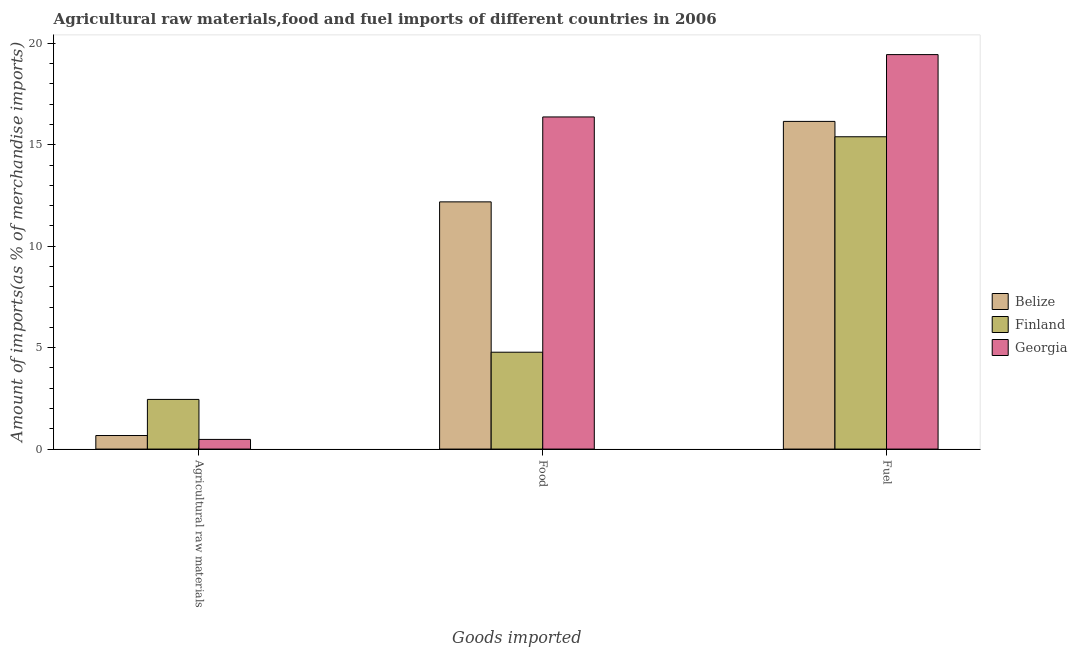How many different coloured bars are there?
Your response must be concise. 3. Are the number of bars per tick equal to the number of legend labels?
Your answer should be compact. Yes. How many bars are there on the 2nd tick from the left?
Ensure brevity in your answer.  3. How many bars are there on the 1st tick from the right?
Keep it short and to the point. 3. What is the label of the 1st group of bars from the left?
Ensure brevity in your answer.  Agricultural raw materials. What is the percentage of raw materials imports in Belize?
Give a very brief answer. 0.67. Across all countries, what is the maximum percentage of raw materials imports?
Your answer should be very brief. 2.45. Across all countries, what is the minimum percentage of fuel imports?
Make the answer very short. 15.39. In which country was the percentage of fuel imports maximum?
Your response must be concise. Georgia. In which country was the percentage of raw materials imports minimum?
Provide a short and direct response. Georgia. What is the total percentage of fuel imports in the graph?
Provide a short and direct response. 50.99. What is the difference between the percentage of fuel imports in Finland and that in Georgia?
Provide a succinct answer. -4.05. What is the difference between the percentage of food imports in Georgia and the percentage of raw materials imports in Finland?
Ensure brevity in your answer.  13.92. What is the average percentage of food imports per country?
Provide a succinct answer. 11.11. What is the difference between the percentage of food imports and percentage of fuel imports in Finland?
Offer a terse response. -10.62. What is the ratio of the percentage of raw materials imports in Finland to that in Belize?
Provide a short and direct response. 3.66. What is the difference between the highest and the second highest percentage of food imports?
Make the answer very short. 4.19. What is the difference between the highest and the lowest percentage of raw materials imports?
Your answer should be very brief. 1.97. In how many countries, is the percentage of fuel imports greater than the average percentage of fuel imports taken over all countries?
Give a very brief answer. 1. What does the 1st bar from the right in Agricultural raw materials represents?
Your response must be concise. Georgia. Is it the case that in every country, the sum of the percentage of raw materials imports and percentage of food imports is greater than the percentage of fuel imports?
Ensure brevity in your answer.  No. How many countries are there in the graph?
Provide a short and direct response. 3. What is the difference between two consecutive major ticks on the Y-axis?
Your answer should be compact. 5. Are the values on the major ticks of Y-axis written in scientific E-notation?
Ensure brevity in your answer.  No. Does the graph contain any zero values?
Your answer should be compact. No. Where does the legend appear in the graph?
Provide a short and direct response. Center right. How are the legend labels stacked?
Give a very brief answer. Vertical. What is the title of the graph?
Your answer should be compact. Agricultural raw materials,food and fuel imports of different countries in 2006. What is the label or title of the X-axis?
Make the answer very short. Goods imported. What is the label or title of the Y-axis?
Your answer should be compact. Amount of imports(as % of merchandise imports). What is the Amount of imports(as % of merchandise imports) of Belize in Agricultural raw materials?
Give a very brief answer. 0.67. What is the Amount of imports(as % of merchandise imports) in Finland in Agricultural raw materials?
Provide a succinct answer. 2.45. What is the Amount of imports(as % of merchandise imports) of Georgia in Agricultural raw materials?
Ensure brevity in your answer.  0.48. What is the Amount of imports(as % of merchandise imports) in Belize in Food?
Keep it short and to the point. 12.18. What is the Amount of imports(as % of merchandise imports) in Finland in Food?
Provide a succinct answer. 4.77. What is the Amount of imports(as % of merchandise imports) of Georgia in Food?
Provide a short and direct response. 16.37. What is the Amount of imports(as % of merchandise imports) of Belize in Fuel?
Your response must be concise. 16.15. What is the Amount of imports(as % of merchandise imports) in Finland in Fuel?
Keep it short and to the point. 15.39. What is the Amount of imports(as % of merchandise imports) of Georgia in Fuel?
Keep it short and to the point. 19.44. Across all Goods imported, what is the maximum Amount of imports(as % of merchandise imports) in Belize?
Keep it short and to the point. 16.15. Across all Goods imported, what is the maximum Amount of imports(as % of merchandise imports) of Finland?
Ensure brevity in your answer.  15.39. Across all Goods imported, what is the maximum Amount of imports(as % of merchandise imports) of Georgia?
Provide a succinct answer. 19.44. Across all Goods imported, what is the minimum Amount of imports(as % of merchandise imports) of Belize?
Make the answer very short. 0.67. Across all Goods imported, what is the minimum Amount of imports(as % of merchandise imports) in Finland?
Provide a succinct answer. 2.45. Across all Goods imported, what is the minimum Amount of imports(as % of merchandise imports) in Georgia?
Make the answer very short. 0.48. What is the total Amount of imports(as % of merchandise imports) of Belize in the graph?
Ensure brevity in your answer.  29. What is the total Amount of imports(as % of merchandise imports) of Finland in the graph?
Provide a short and direct response. 22.62. What is the total Amount of imports(as % of merchandise imports) in Georgia in the graph?
Ensure brevity in your answer.  36.29. What is the difference between the Amount of imports(as % of merchandise imports) in Belize in Agricultural raw materials and that in Food?
Offer a terse response. -11.52. What is the difference between the Amount of imports(as % of merchandise imports) in Finland in Agricultural raw materials and that in Food?
Your answer should be compact. -2.33. What is the difference between the Amount of imports(as % of merchandise imports) in Georgia in Agricultural raw materials and that in Food?
Provide a short and direct response. -15.89. What is the difference between the Amount of imports(as % of merchandise imports) of Belize in Agricultural raw materials and that in Fuel?
Provide a short and direct response. -15.48. What is the difference between the Amount of imports(as % of merchandise imports) in Finland in Agricultural raw materials and that in Fuel?
Provide a succinct answer. -12.95. What is the difference between the Amount of imports(as % of merchandise imports) of Georgia in Agricultural raw materials and that in Fuel?
Provide a short and direct response. -18.97. What is the difference between the Amount of imports(as % of merchandise imports) of Belize in Food and that in Fuel?
Provide a succinct answer. -3.97. What is the difference between the Amount of imports(as % of merchandise imports) of Finland in Food and that in Fuel?
Your answer should be compact. -10.62. What is the difference between the Amount of imports(as % of merchandise imports) of Georgia in Food and that in Fuel?
Keep it short and to the point. -3.07. What is the difference between the Amount of imports(as % of merchandise imports) of Belize in Agricultural raw materials and the Amount of imports(as % of merchandise imports) of Finland in Food?
Offer a very short reply. -4.11. What is the difference between the Amount of imports(as % of merchandise imports) in Belize in Agricultural raw materials and the Amount of imports(as % of merchandise imports) in Georgia in Food?
Ensure brevity in your answer.  -15.7. What is the difference between the Amount of imports(as % of merchandise imports) of Finland in Agricultural raw materials and the Amount of imports(as % of merchandise imports) of Georgia in Food?
Your response must be concise. -13.92. What is the difference between the Amount of imports(as % of merchandise imports) in Belize in Agricultural raw materials and the Amount of imports(as % of merchandise imports) in Finland in Fuel?
Your response must be concise. -14.73. What is the difference between the Amount of imports(as % of merchandise imports) in Belize in Agricultural raw materials and the Amount of imports(as % of merchandise imports) in Georgia in Fuel?
Your answer should be very brief. -18.77. What is the difference between the Amount of imports(as % of merchandise imports) of Finland in Agricultural raw materials and the Amount of imports(as % of merchandise imports) of Georgia in Fuel?
Make the answer very short. -17. What is the difference between the Amount of imports(as % of merchandise imports) of Belize in Food and the Amount of imports(as % of merchandise imports) of Finland in Fuel?
Your answer should be very brief. -3.21. What is the difference between the Amount of imports(as % of merchandise imports) in Belize in Food and the Amount of imports(as % of merchandise imports) in Georgia in Fuel?
Your response must be concise. -7.26. What is the difference between the Amount of imports(as % of merchandise imports) in Finland in Food and the Amount of imports(as % of merchandise imports) in Georgia in Fuel?
Provide a short and direct response. -14.67. What is the average Amount of imports(as % of merchandise imports) in Belize per Goods imported?
Your response must be concise. 9.67. What is the average Amount of imports(as % of merchandise imports) in Finland per Goods imported?
Make the answer very short. 7.54. What is the average Amount of imports(as % of merchandise imports) in Georgia per Goods imported?
Your response must be concise. 12.1. What is the difference between the Amount of imports(as % of merchandise imports) in Belize and Amount of imports(as % of merchandise imports) in Finland in Agricultural raw materials?
Provide a short and direct response. -1.78. What is the difference between the Amount of imports(as % of merchandise imports) in Belize and Amount of imports(as % of merchandise imports) in Georgia in Agricultural raw materials?
Provide a succinct answer. 0.19. What is the difference between the Amount of imports(as % of merchandise imports) in Finland and Amount of imports(as % of merchandise imports) in Georgia in Agricultural raw materials?
Keep it short and to the point. 1.97. What is the difference between the Amount of imports(as % of merchandise imports) of Belize and Amount of imports(as % of merchandise imports) of Finland in Food?
Your response must be concise. 7.41. What is the difference between the Amount of imports(as % of merchandise imports) in Belize and Amount of imports(as % of merchandise imports) in Georgia in Food?
Your answer should be very brief. -4.19. What is the difference between the Amount of imports(as % of merchandise imports) in Finland and Amount of imports(as % of merchandise imports) in Georgia in Food?
Your answer should be very brief. -11.6. What is the difference between the Amount of imports(as % of merchandise imports) in Belize and Amount of imports(as % of merchandise imports) in Finland in Fuel?
Offer a terse response. 0.76. What is the difference between the Amount of imports(as % of merchandise imports) in Belize and Amount of imports(as % of merchandise imports) in Georgia in Fuel?
Give a very brief answer. -3.29. What is the difference between the Amount of imports(as % of merchandise imports) in Finland and Amount of imports(as % of merchandise imports) in Georgia in Fuel?
Offer a very short reply. -4.05. What is the ratio of the Amount of imports(as % of merchandise imports) of Belize in Agricultural raw materials to that in Food?
Provide a short and direct response. 0.05. What is the ratio of the Amount of imports(as % of merchandise imports) in Finland in Agricultural raw materials to that in Food?
Make the answer very short. 0.51. What is the ratio of the Amount of imports(as % of merchandise imports) of Georgia in Agricultural raw materials to that in Food?
Offer a terse response. 0.03. What is the ratio of the Amount of imports(as % of merchandise imports) of Belize in Agricultural raw materials to that in Fuel?
Make the answer very short. 0.04. What is the ratio of the Amount of imports(as % of merchandise imports) of Finland in Agricultural raw materials to that in Fuel?
Give a very brief answer. 0.16. What is the ratio of the Amount of imports(as % of merchandise imports) in Georgia in Agricultural raw materials to that in Fuel?
Provide a short and direct response. 0.02. What is the ratio of the Amount of imports(as % of merchandise imports) in Belize in Food to that in Fuel?
Provide a succinct answer. 0.75. What is the ratio of the Amount of imports(as % of merchandise imports) of Finland in Food to that in Fuel?
Your answer should be very brief. 0.31. What is the ratio of the Amount of imports(as % of merchandise imports) in Georgia in Food to that in Fuel?
Provide a succinct answer. 0.84. What is the difference between the highest and the second highest Amount of imports(as % of merchandise imports) of Belize?
Offer a terse response. 3.97. What is the difference between the highest and the second highest Amount of imports(as % of merchandise imports) of Finland?
Keep it short and to the point. 10.62. What is the difference between the highest and the second highest Amount of imports(as % of merchandise imports) in Georgia?
Provide a succinct answer. 3.07. What is the difference between the highest and the lowest Amount of imports(as % of merchandise imports) of Belize?
Offer a terse response. 15.48. What is the difference between the highest and the lowest Amount of imports(as % of merchandise imports) in Finland?
Ensure brevity in your answer.  12.95. What is the difference between the highest and the lowest Amount of imports(as % of merchandise imports) of Georgia?
Your response must be concise. 18.97. 